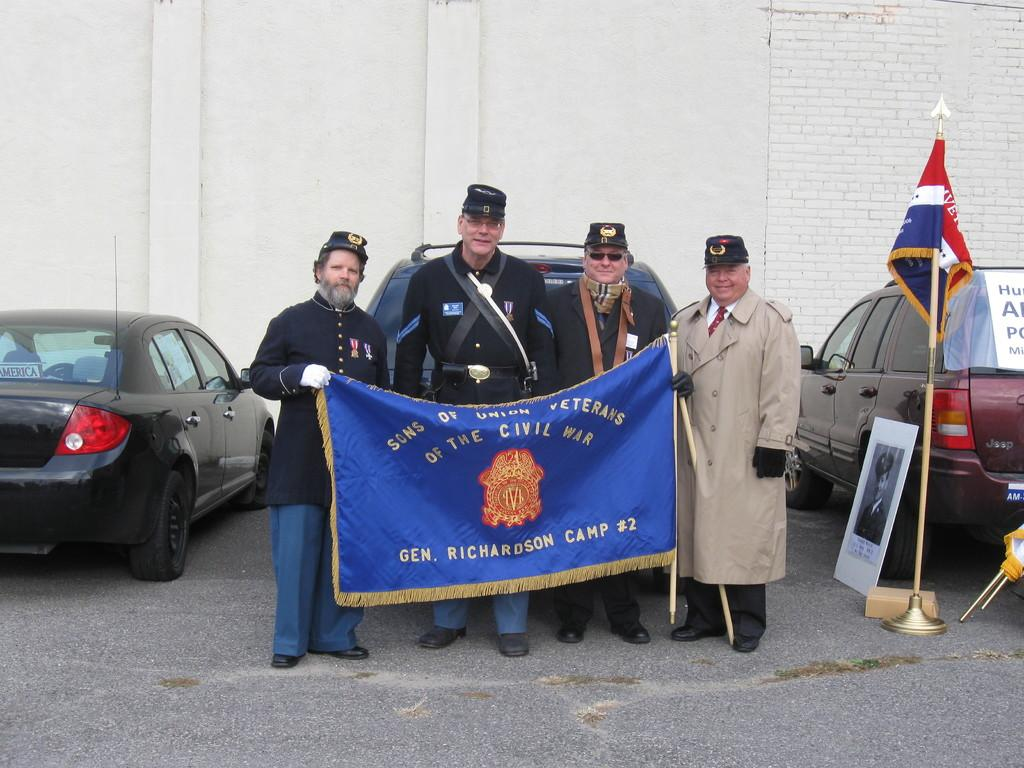What are the people in the image doing? The people in the image are standing and holding a banner. What else can be seen in the image besides the people? Cars, placards, and flags are visible in the image. What is in the background of the image? There is a wall in the background of the image. What time does the clock in the image show? There is no clock present in the image. What type of battle is depicted in the image? There is no battle depicted in the image; it features people holding a banner, cars, placards, and flags. 